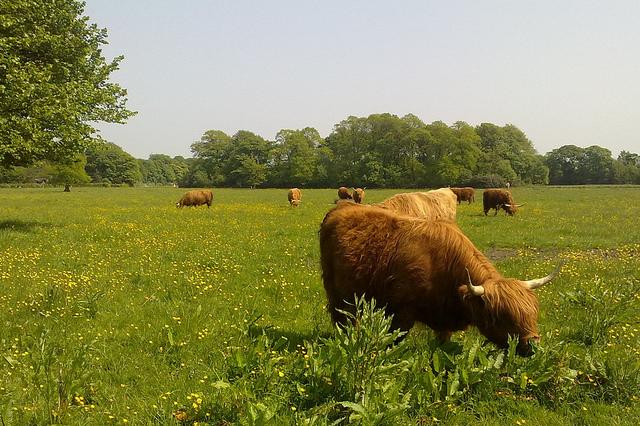Are these buffalos?
Write a very short answer. No. Does the animals have horns?
Write a very short answer. Yes. How many animals?
Concise answer only. 8. 